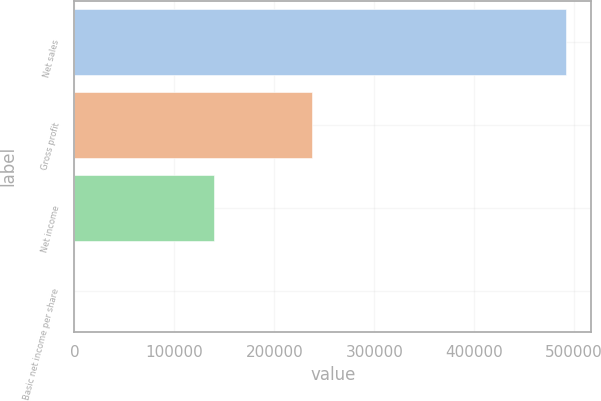Convert chart to OTSL. <chart><loc_0><loc_0><loc_500><loc_500><bar_chart><fcel>Net sales<fcel>Gross profit<fcel>Net income<fcel>Basic net income per share<nl><fcel>492159<fcel>237752<fcel>139860<fcel>0.65<nl></chart> 